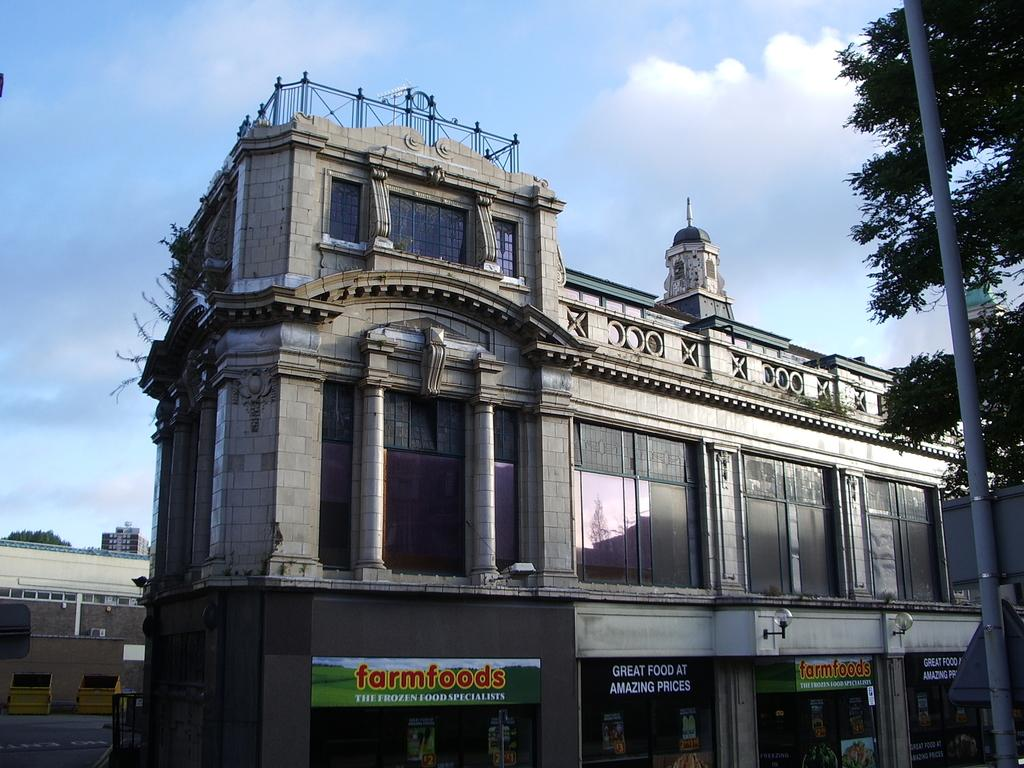<image>
Share a concise interpretation of the image provided. A beautiful building for Farmfoods that sell frozen food with an amazing price. 